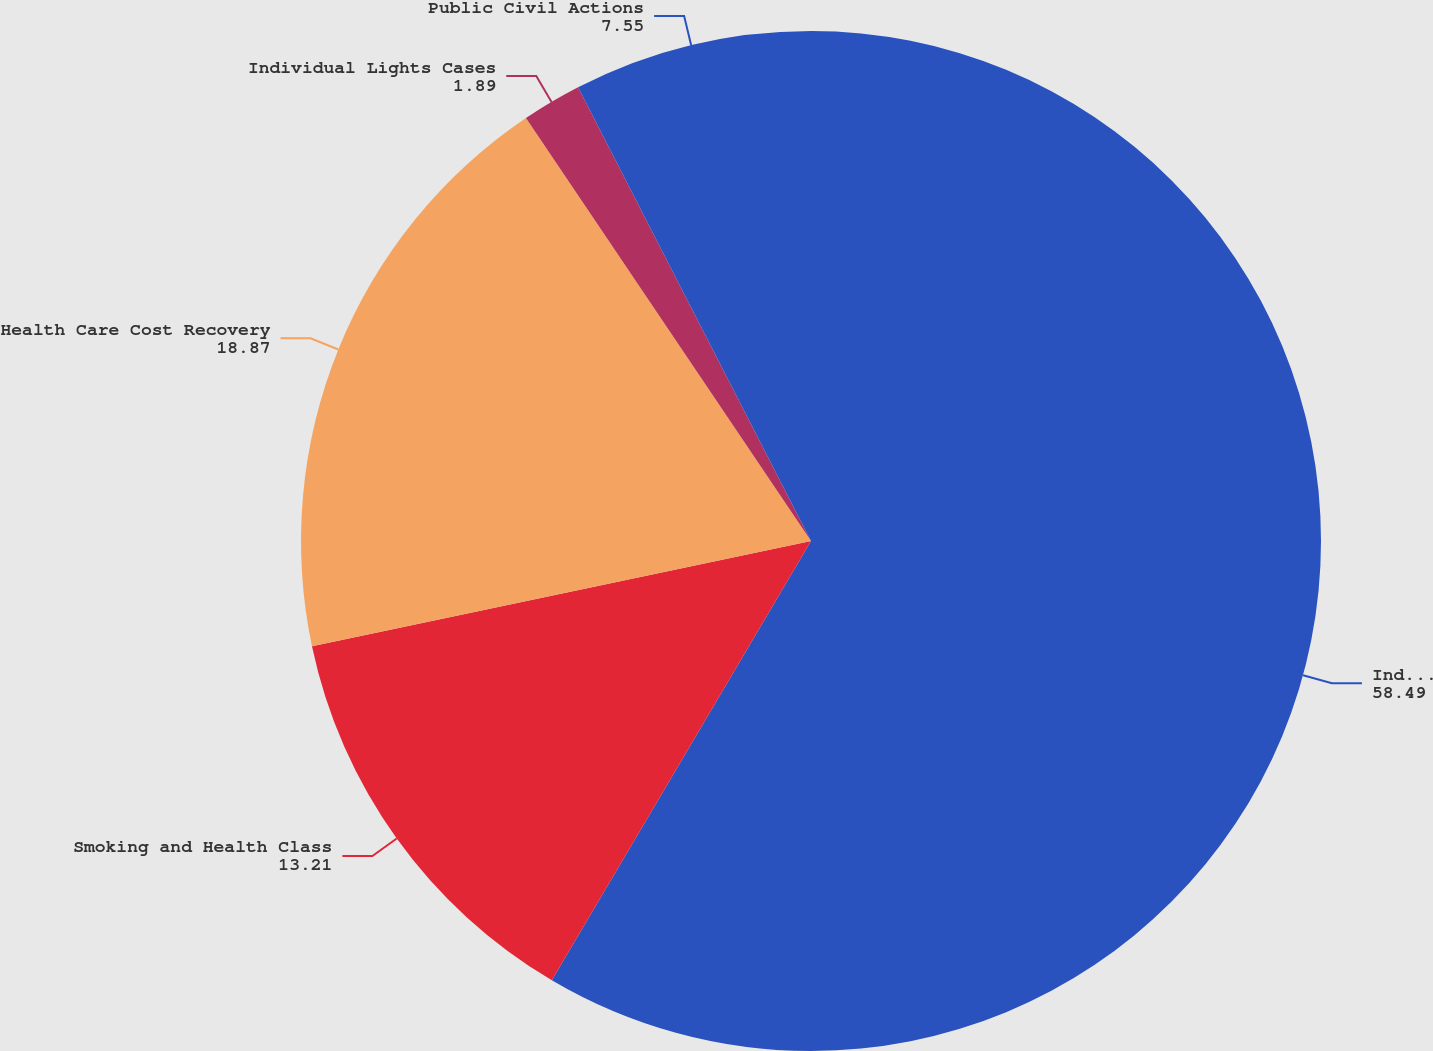Convert chart. <chart><loc_0><loc_0><loc_500><loc_500><pie_chart><fcel>Individual Smoking and Health<fcel>Smoking and Health Class<fcel>Health Care Cost Recovery<fcel>Individual Lights Cases<fcel>Public Civil Actions<nl><fcel>58.49%<fcel>13.21%<fcel>18.87%<fcel>1.89%<fcel>7.55%<nl></chart> 